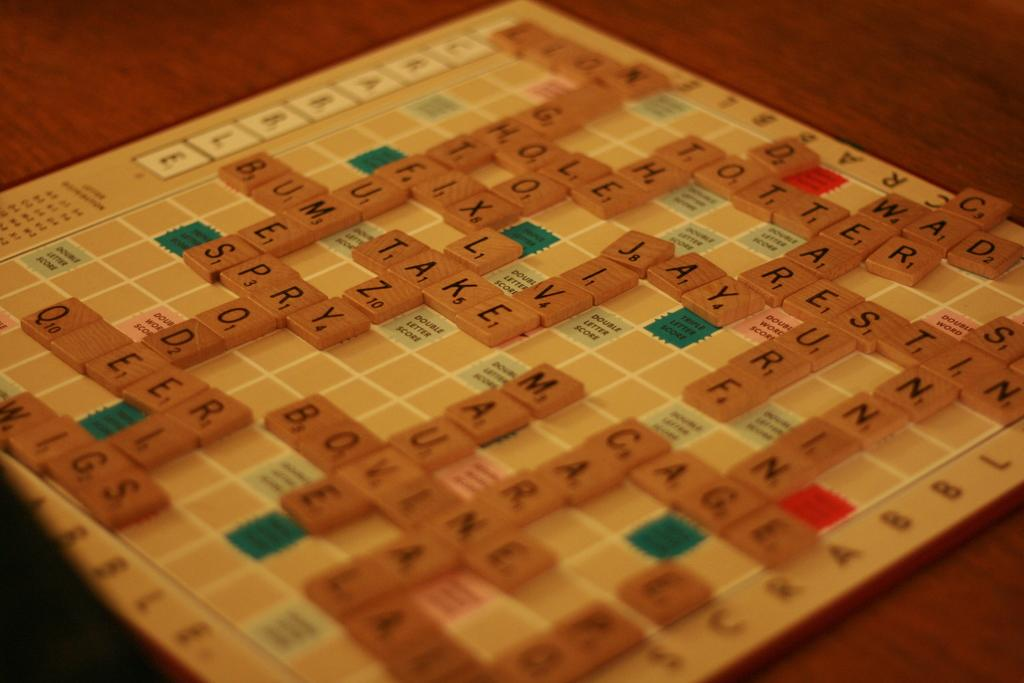What is the main object in the image? There is a word puzzle board in the image. Where is the word puzzle board located? The word puzzle board is kept on a table. What can be seen on the word puzzle board? There are words arranged on the puzzle board. Who is the uncle holding the surprise card in the image? There is no uncle or surprise card present in the image; it only features a word puzzle board on a table. 